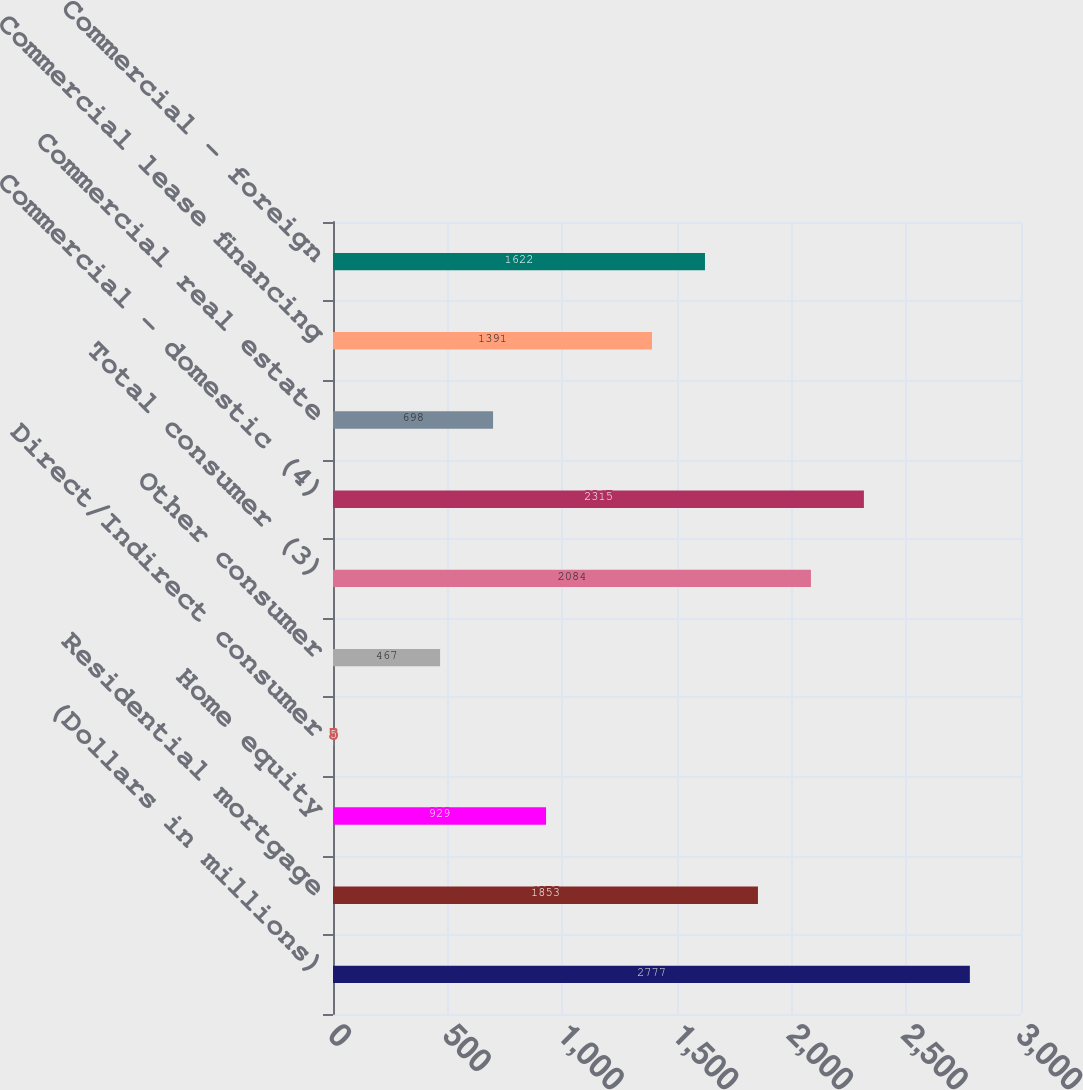Convert chart. <chart><loc_0><loc_0><loc_500><loc_500><bar_chart><fcel>(Dollars in millions)<fcel>Residential mortgage<fcel>Home equity<fcel>Direct/Indirect consumer<fcel>Other consumer<fcel>Total consumer (3)<fcel>Commercial - domestic (4)<fcel>Commercial real estate<fcel>Commercial lease financing<fcel>Commercial - foreign<nl><fcel>2777<fcel>1853<fcel>929<fcel>5<fcel>467<fcel>2084<fcel>2315<fcel>698<fcel>1391<fcel>1622<nl></chart> 